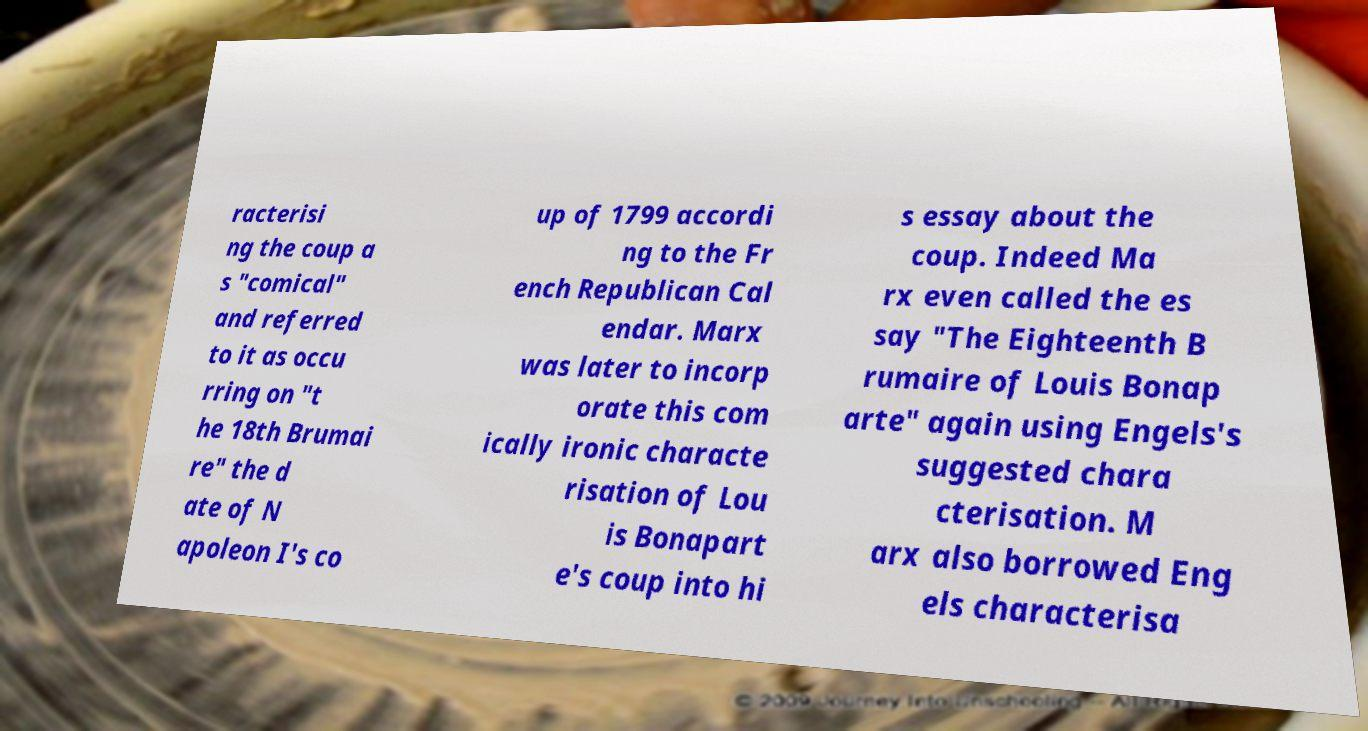Could you assist in decoding the text presented in this image and type it out clearly? racterisi ng the coup a s "comical" and referred to it as occu rring on "t he 18th Brumai re" the d ate of N apoleon I's co up of 1799 accordi ng to the Fr ench Republican Cal endar. Marx was later to incorp orate this com ically ironic characte risation of Lou is Bonapart e's coup into hi s essay about the coup. Indeed Ma rx even called the es say "The Eighteenth B rumaire of Louis Bonap arte" again using Engels's suggested chara cterisation. M arx also borrowed Eng els characterisa 